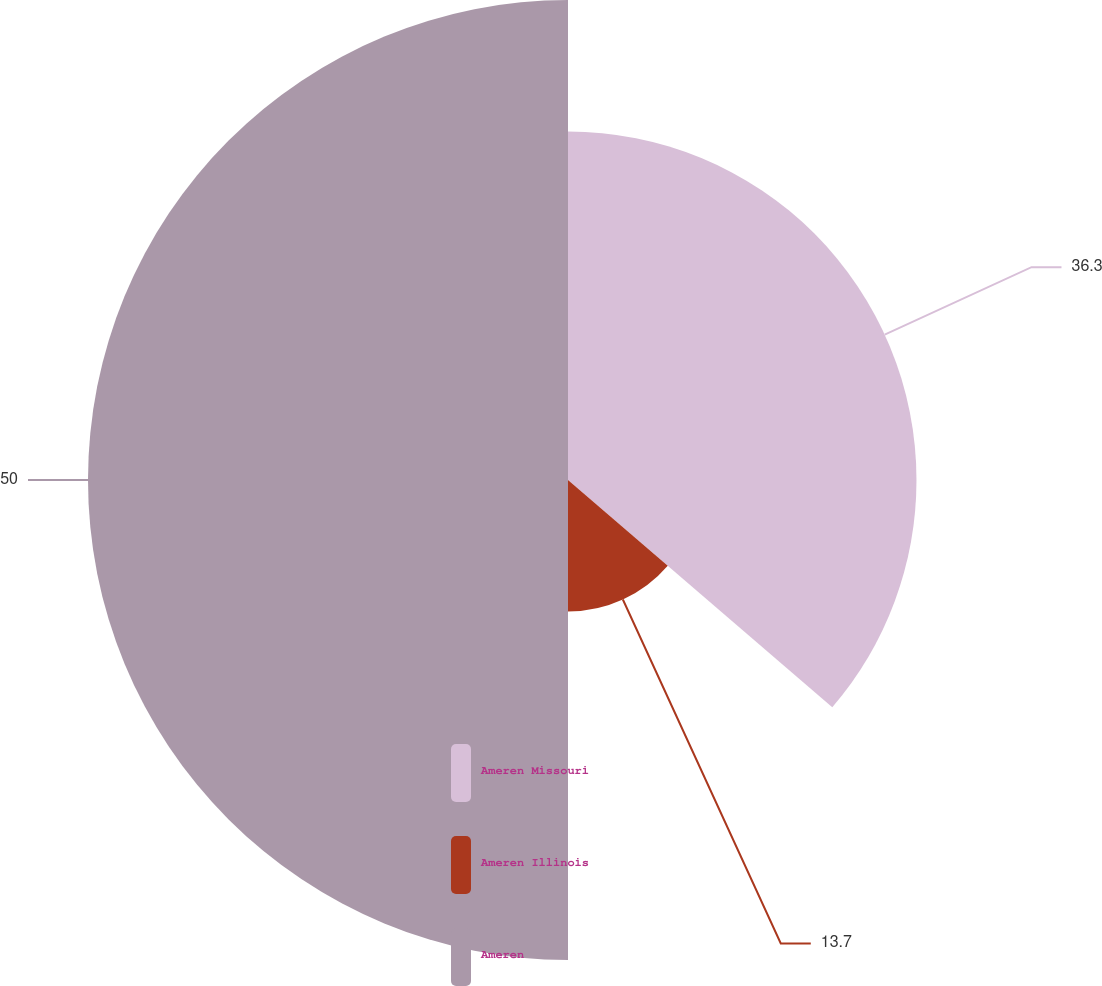Convert chart. <chart><loc_0><loc_0><loc_500><loc_500><pie_chart><fcel>Ameren Missouri<fcel>Ameren Illinois<fcel>Ameren<nl><fcel>36.3%<fcel>13.7%<fcel>50.0%<nl></chart> 